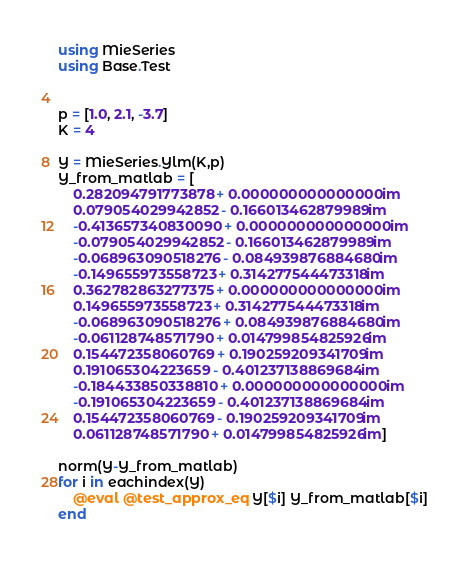Convert code to text. <code><loc_0><loc_0><loc_500><loc_500><_Julia_>using MieSeries
using Base.Test


p = [1.0, 2.1, -3.7]
K = 4

Y = MieSeries.Ylm(K,p)
Y_from_matlab = [
    0.282094791773878 + 0.000000000000000im
    0.079054029942852 - 0.166013462879989im
    -0.413657340830090 + 0.000000000000000im
    -0.079054029942852 - 0.166013462879989im
    -0.068963090518276 - 0.084939876884680im
    -0.149655973558723 + 0.314277544473318im
    0.362782863277375 + 0.000000000000000im
    0.149655973558723 + 0.314277544473318im
    -0.068963090518276 + 0.084939876884680im
    -0.061128748571790 + 0.014799854825926im
    0.154472358060769 + 0.190259209341709im
    0.191065304223659 - 0.401237138869684im
    -0.184433850338810 + 0.000000000000000im
    -0.191065304223659 - 0.401237138869684im
    0.154472358060769 - 0.190259209341709im
    0.061128748571790 + 0.014799854825926im]

norm(Y-Y_from_matlab)
for i in eachindex(Y)
    @eval @test_approx_eq Y[$i] Y_from_matlab[$i]
end
</code> 